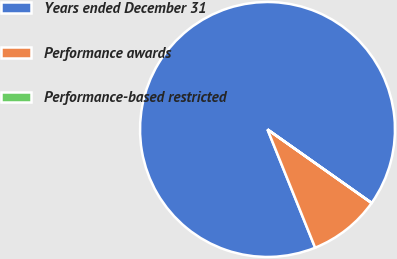Convert chart. <chart><loc_0><loc_0><loc_500><loc_500><pie_chart><fcel>Years ended December 31<fcel>Performance awards<fcel>Performance-based restricted<nl><fcel>90.87%<fcel>9.11%<fcel>0.02%<nl></chart> 